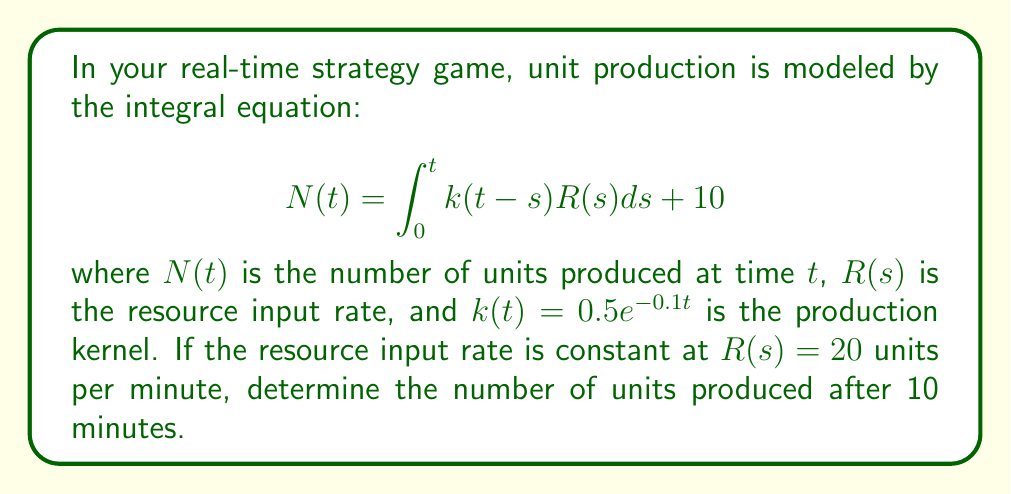Give your solution to this math problem. 1) First, we substitute the given values into the integral equation:

   $$N(10) = \int_0^{10} 0.5e^{-0.1(10-s)} \cdot 20 ds + 10$$

2) Simplify the constant terms:

   $$N(10) = 10 \int_0^{10} e^{-0.1(10-s)} ds + 10$$

3) Let $u = 10-s$, then $du = -ds$. When $s = 0$, $u = 10$; when $s = 10$, $u = 0$. Substituting:

   $$N(10) = -10 \int_{10}^0 e^{-0.1u} du + 10$$

4) Evaluate the integral:

   $$N(10) = -10 \left[-\frac{1}{0.1}e^{-0.1u}\right]_0^{10} + 10$$

5) Solve the definite integral:

   $$N(10) = -10 \left(-\frac{1}{0.1}e^{-1} + \frac{1}{0.1}\right) + 10$$

6) Simplify:

   $$N(10) = 100(1 - e^{-1}) + 10$$

7) Calculate the final result:

   $$N(10) \approx 73.58$$
Answer: 74 units (rounded to nearest whole unit) 